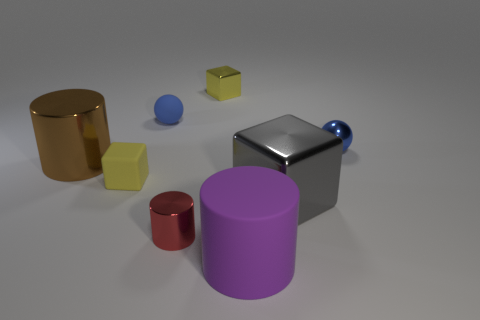There is another shiny object that is the same shape as the gray metal thing; what is its color?
Offer a very short reply. Yellow. Do the blue metallic object and the yellow rubber thing have the same shape?
Your answer should be very brief. No. How many balls are small red objects or gray metal things?
Ensure brevity in your answer.  0. What color is the other big thing that is the same material as the gray object?
Your answer should be very brief. Brown. There is a metal block that is behind the gray block; is its size the same as the big gray cube?
Offer a terse response. No. Is the material of the gray cube the same as the small yellow block that is in front of the big brown shiny cylinder?
Ensure brevity in your answer.  No. There is a tiny thing that is on the right side of the large gray block; what color is it?
Ensure brevity in your answer.  Blue. Are there any red metallic things to the left of the tiny object that is in front of the matte cube?
Offer a very short reply. No. There is a cube on the left side of the red thing; is its color the same as the tiny cube that is on the right side of the tiny metal cylinder?
Keep it short and to the point. Yes. How many blue objects are on the right side of the tiny blue rubber thing?
Keep it short and to the point. 1. 